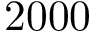<formula> <loc_0><loc_0><loc_500><loc_500>2 0 0 0</formula> 